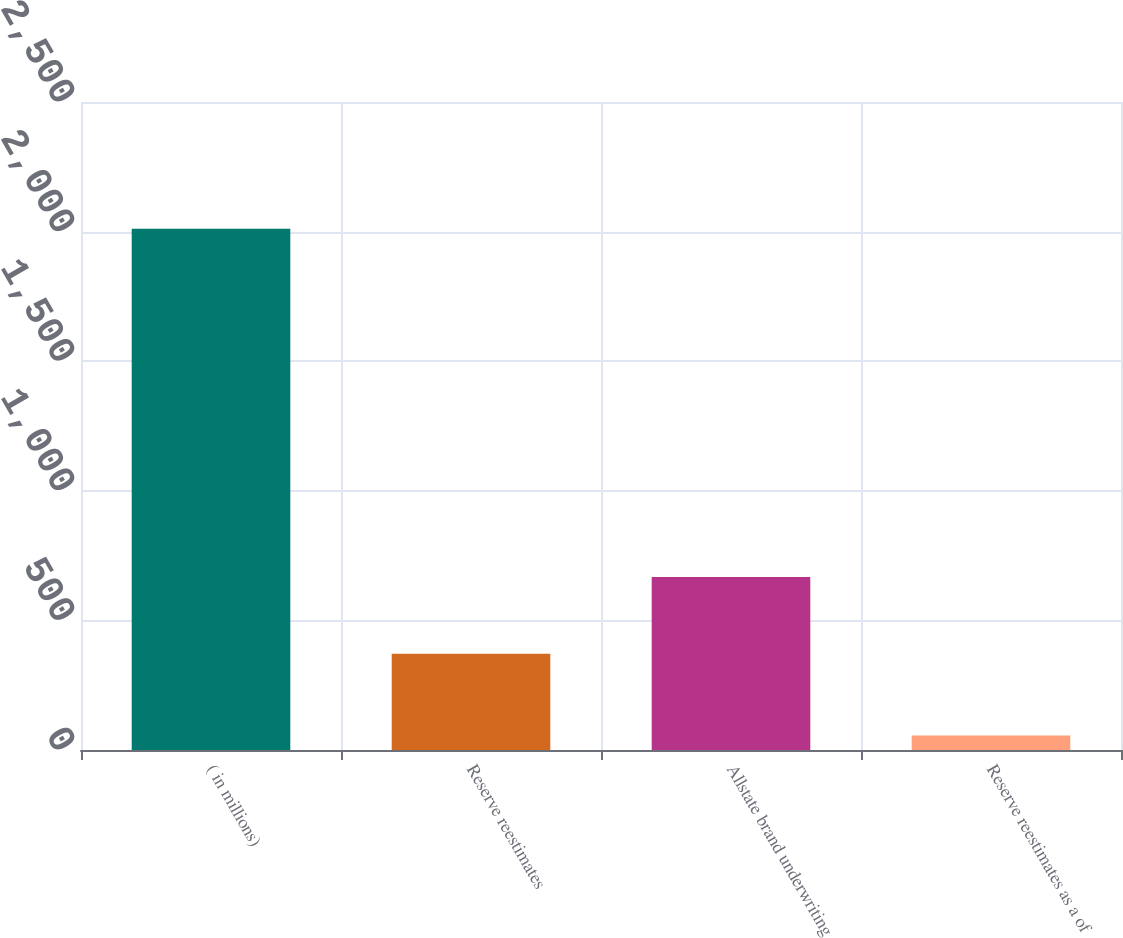Convert chart to OTSL. <chart><loc_0><loc_0><loc_500><loc_500><bar_chart><fcel>( in millions)<fcel>Reserve reestimates<fcel>Allstate brand underwriting<fcel>Reserve reestimates as a of<nl><fcel>2011<fcel>371<fcel>667<fcel>55.6<nl></chart> 